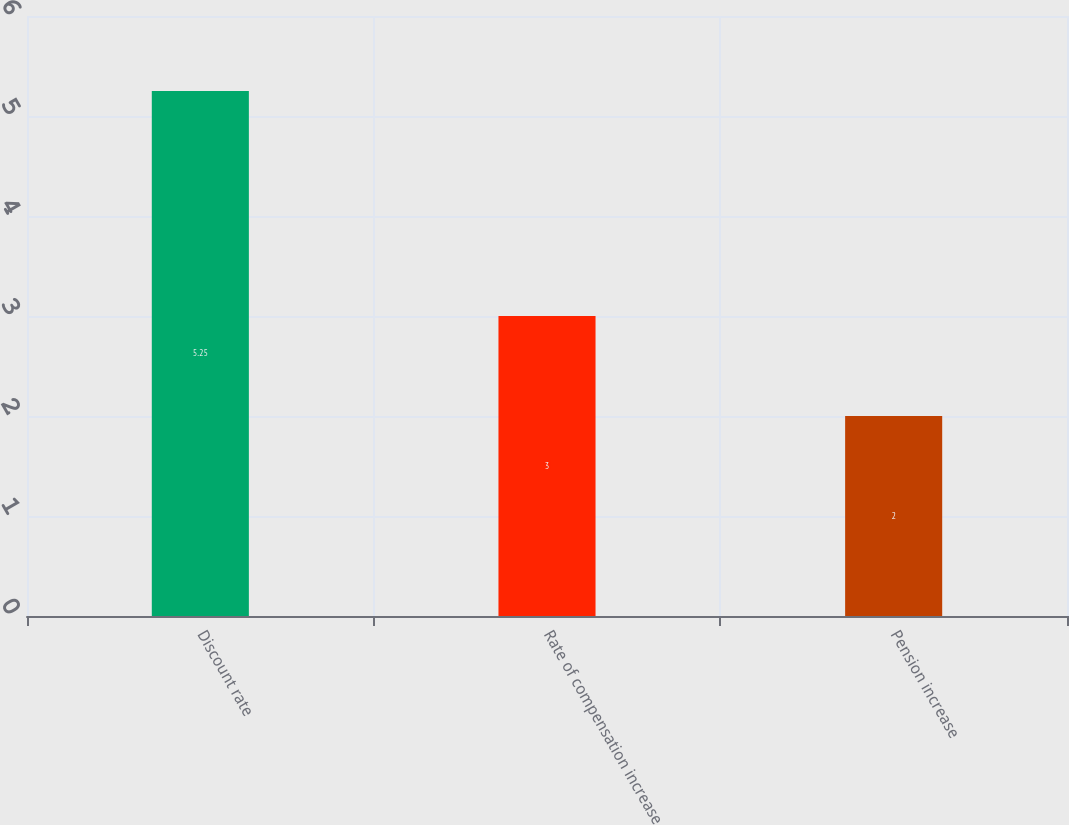<chart> <loc_0><loc_0><loc_500><loc_500><bar_chart><fcel>Discount rate<fcel>Rate of compensation increase<fcel>Pension increase<nl><fcel>5.25<fcel>3<fcel>2<nl></chart> 